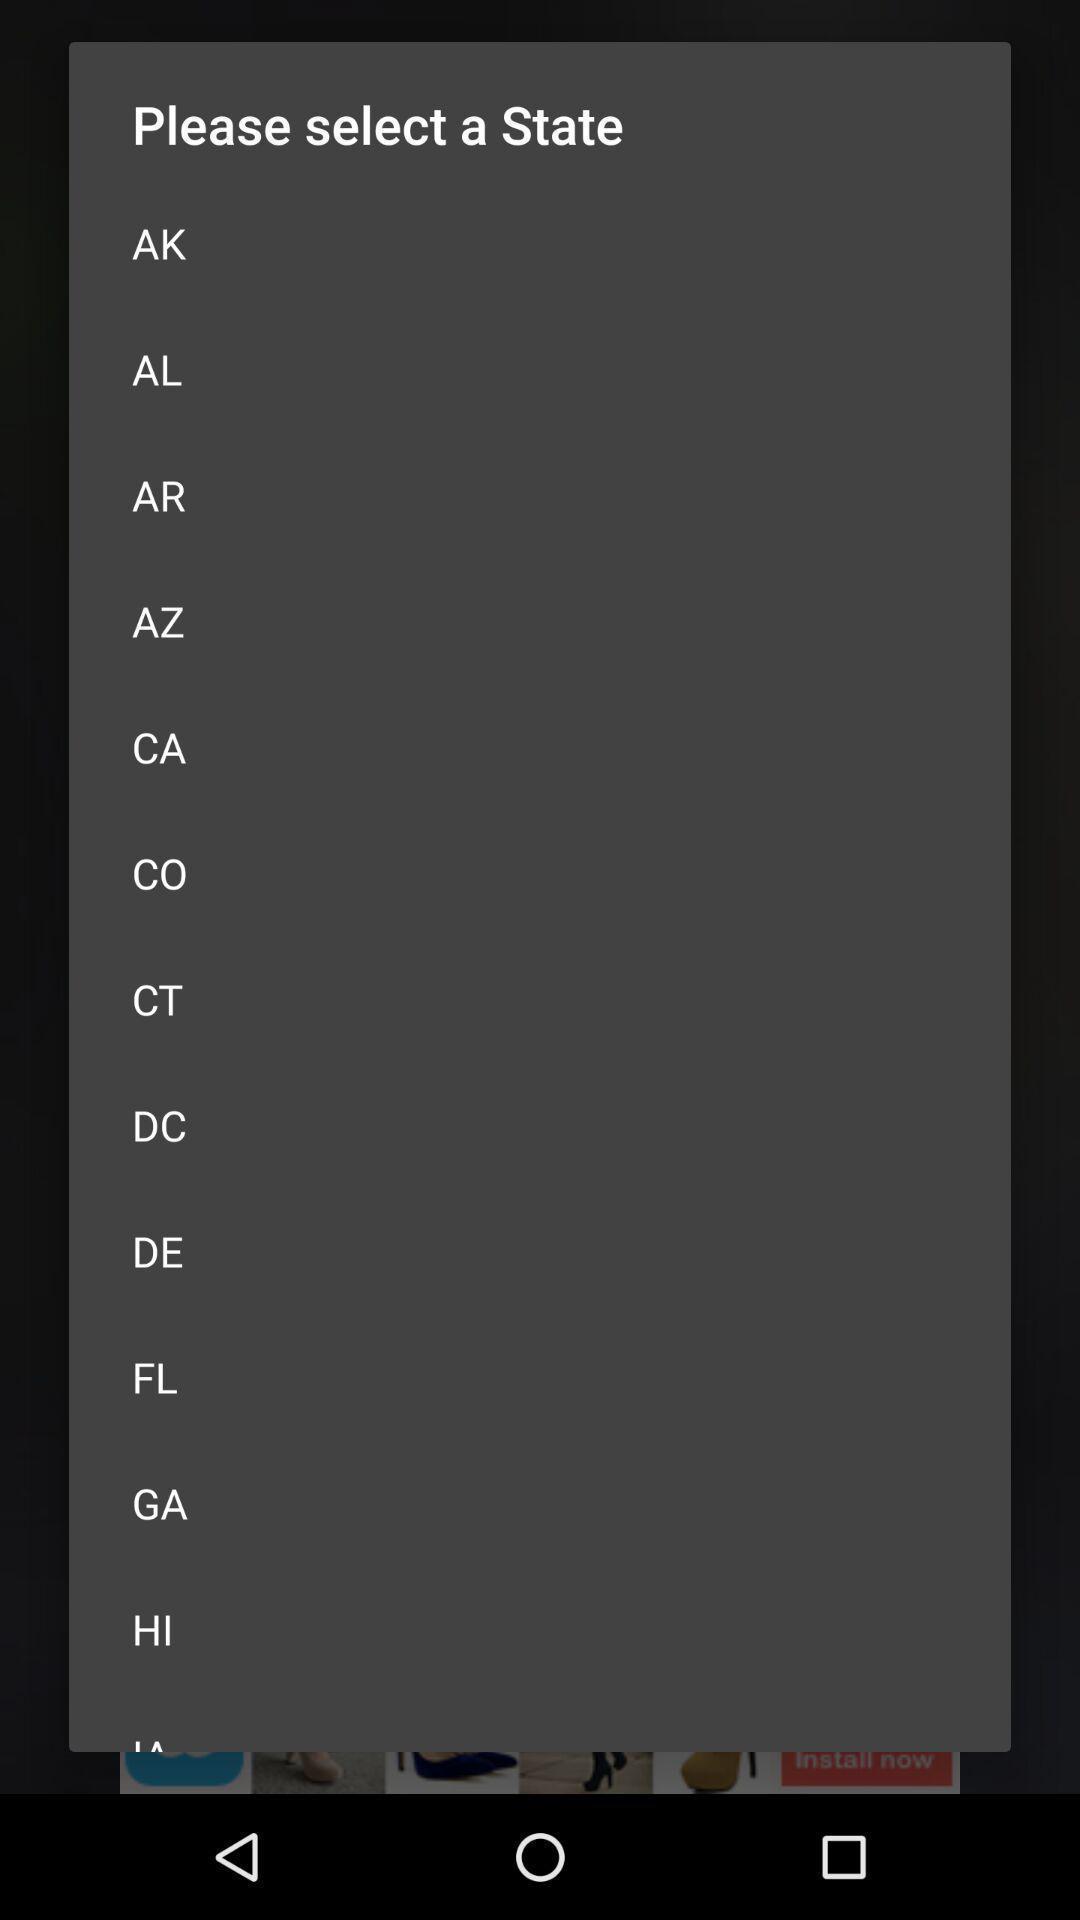Provide a detailed account of this screenshot. Pop-up to select a state. 